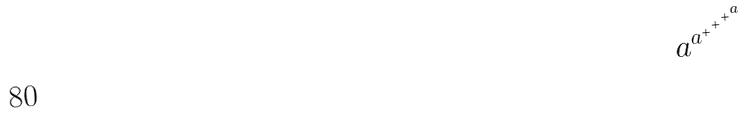Convert formula to latex. <formula><loc_0><loc_0><loc_500><loc_500>a ^ { a ^ { + ^ { + ^ { + ^ { a } } } } }</formula> 